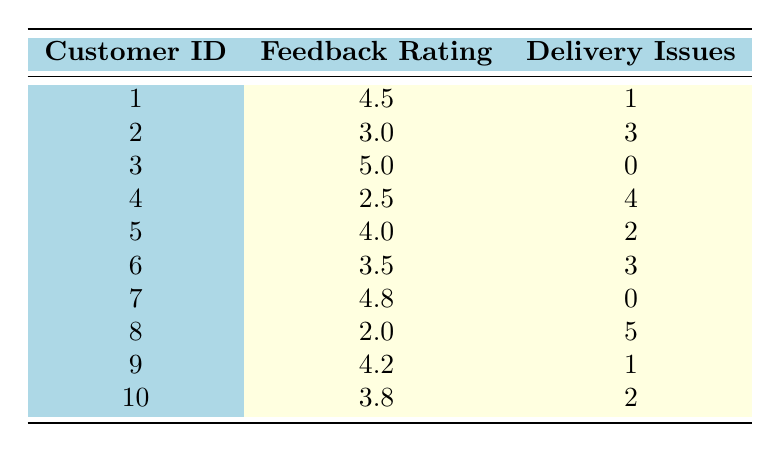What is the customer feedback rating of customer ID 3? The table shows the feedback ratings for each customer. Looking at the row for customer ID 3, we find that the feedback rating is 5.0.
Answer: 5.0 How many delivery issues did customer ID 8 experience? In the table, the row for customer ID 8 indicates that they experienced 5 delivery issues.
Answer: 5 What is the highest customer feedback rating in the table? To find the highest rating, we can look at all the feedback ratings listed. The highest value among 4.5, 3.0, 5.0, 2.5, 4.0, 3.5, 4.8, 2.0, 4.2, and 3.8 is 5.0.
Answer: 5.0 What is the average customer feedback rating among customers with zero delivery issues? The customers with zero delivery issues are customer ID 3 (5.0) and customer ID 7 (4.8). Adding these ratings gives 5.0 + 4.8 = 9.8. There are 2 such customers, so the average is 9.8 divided by 2, which is 4.9.
Answer: 4.9 Did any customer with a feedback rating below 3.0 experience zero delivery issues? Looking at the feedback ratings below 3.0, we see customer ID 4 (2.5) and customer ID 8 (2.0) both have delivery issues (4 and 5, respectively). Therefore, no customer with a feedback rating below 3.0 has zero delivery issues.
Answer: No How many customers rated their feedback higher than 4.0 and reported more than 1 delivery issue? The customers with feedback ratings higher than 4.0 are customer ID 1 (4.5), customer ID 3 (5.0), customer ID 5 (4.0), and customer ID 7 (4.8). Out of these, customer ID 5 (2 issues) qualifies, but the others do not have more than 1, so there is 1 customer that meets the criteria.
Answer: 1 What is the feedback rating for the customer who had the most delivery issues? Customer ID 8 has the highest delivery issues at 5. Looking at the table, the feedback rating for customer ID 8 is 2.0.
Answer: 2.0 How many customers have a feedback rating below 3.0? By inspecting the table, we find that customer ID 4 (2.5) and customer ID 8 (2.0) have feedback ratings below 3.0. Therefore, there are 2 customers with a rating below 3.0.
Answer: 2 Are there any customers who provided a feedback rating of 4.0 or higher with 0 delivery issues? Looking at the customers with a rating of 4.0 or higher, customer ID 3 (5.0) and customer ID 7 (4.8) have 0 delivery issues. So there are indeed customers meeting this criteria.
Answer: Yes 